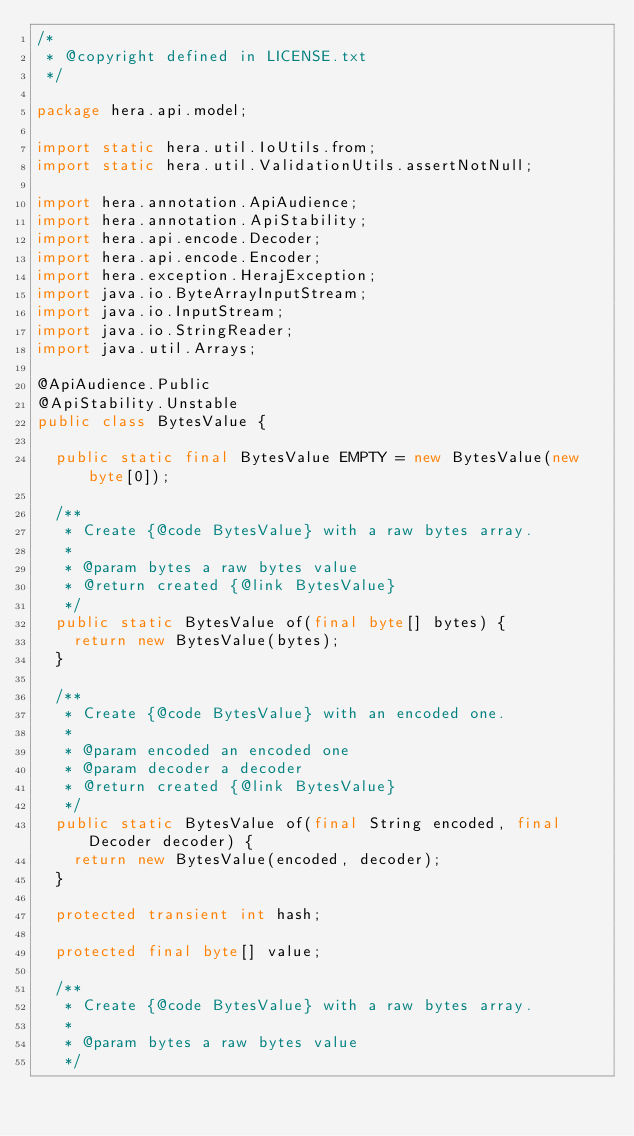Convert code to text. <code><loc_0><loc_0><loc_500><loc_500><_Java_>/*
 * @copyright defined in LICENSE.txt
 */

package hera.api.model;

import static hera.util.IoUtils.from;
import static hera.util.ValidationUtils.assertNotNull;

import hera.annotation.ApiAudience;
import hera.annotation.ApiStability;
import hera.api.encode.Decoder;
import hera.api.encode.Encoder;
import hera.exception.HerajException;
import java.io.ByteArrayInputStream;
import java.io.InputStream;
import java.io.StringReader;
import java.util.Arrays;

@ApiAudience.Public
@ApiStability.Unstable
public class BytesValue {

  public static final BytesValue EMPTY = new BytesValue(new byte[0]);

  /**
   * Create {@code BytesValue} with a raw bytes array.
   *
   * @param bytes a raw bytes value
   * @return created {@link BytesValue}
   */
  public static BytesValue of(final byte[] bytes) {
    return new BytesValue(bytes);
  }

  /**
   * Create {@code BytesValue} with an encoded one.
   *
   * @param encoded an encoded one
   * @param decoder a decoder
   * @return created {@link BytesValue}
   */
  public static BytesValue of(final String encoded, final Decoder decoder) {
    return new BytesValue(encoded, decoder);
  }

  protected transient int hash;

  protected final byte[] value;

  /**
   * Create {@code BytesValue} with a raw bytes array.
   *
   * @param bytes a raw bytes value
   */</code> 